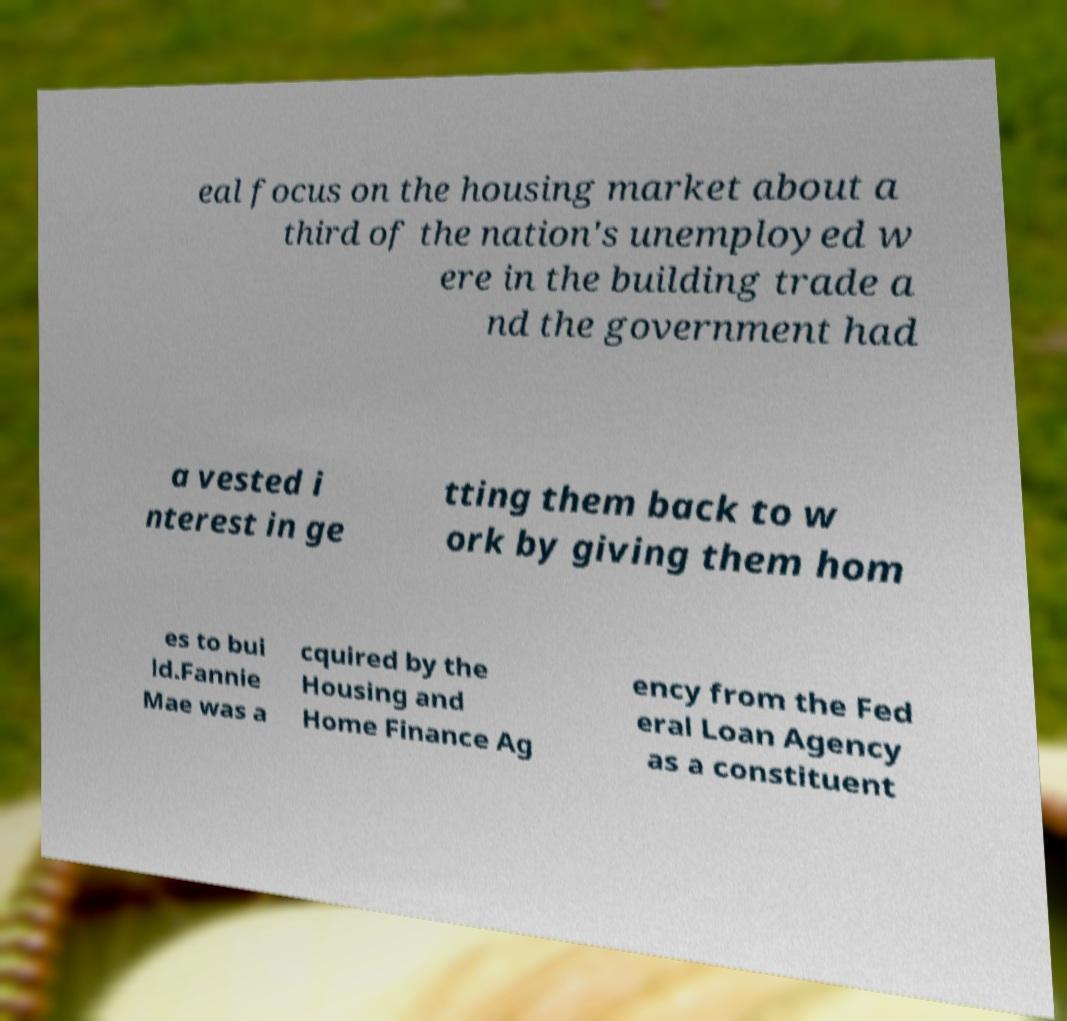Could you extract and type out the text from this image? eal focus on the housing market about a third of the nation's unemployed w ere in the building trade a nd the government had a vested i nterest in ge tting them back to w ork by giving them hom es to bui ld.Fannie Mae was a cquired by the Housing and Home Finance Ag ency from the Fed eral Loan Agency as a constituent 